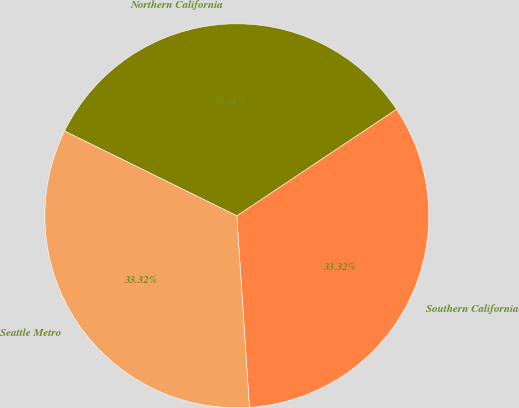Convert chart to OTSL. <chart><loc_0><loc_0><loc_500><loc_500><pie_chart><fcel>Southern California<fcel>Northern California<fcel>Seattle Metro<nl><fcel>33.32%<fcel>33.36%<fcel>33.32%<nl></chart> 